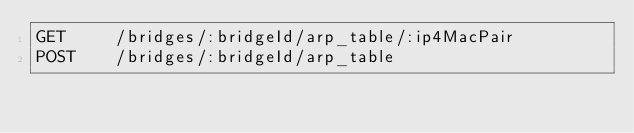<code> <loc_0><loc_0><loc_500><loc_500><_HTML_>GET     /bridges/:bridgeId/arp_table/:ip4MacPair
POST    /bridges/:bridgeId/arp_table</code> 